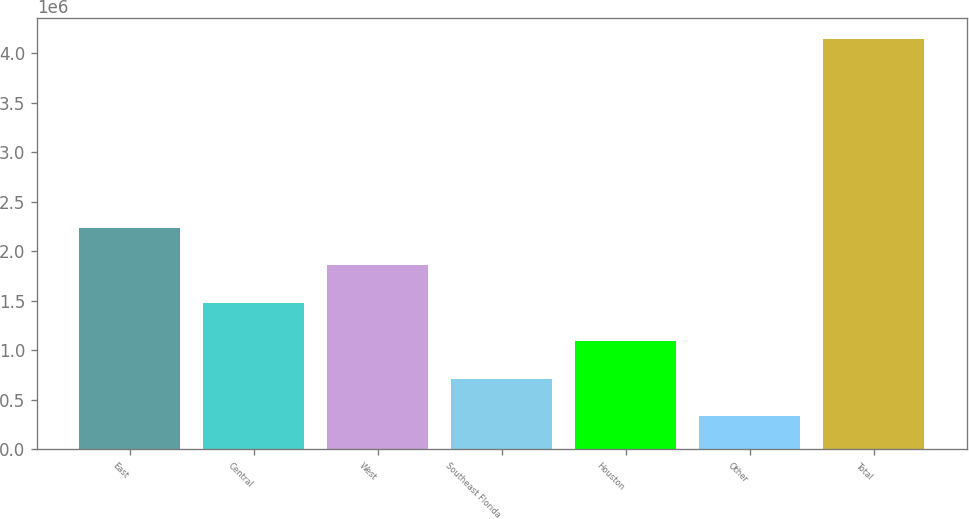Convert chart to OTSL. <chart><loc_0><loc_0><loc_500><loc_500><bar_chart><fcel>East<fcel>Central<fcel>West<fcel>Southeast Florida<fcel>Houston<fcel>Other<fcel>Total<nl><fcel>2.23886e+06<fcel>1.47661e+06<fcel>1.85774e+06<fcel>714358<fcel>1.09548e+06<fcel>333232<fcel>4.14449e+06<nl></chart> 